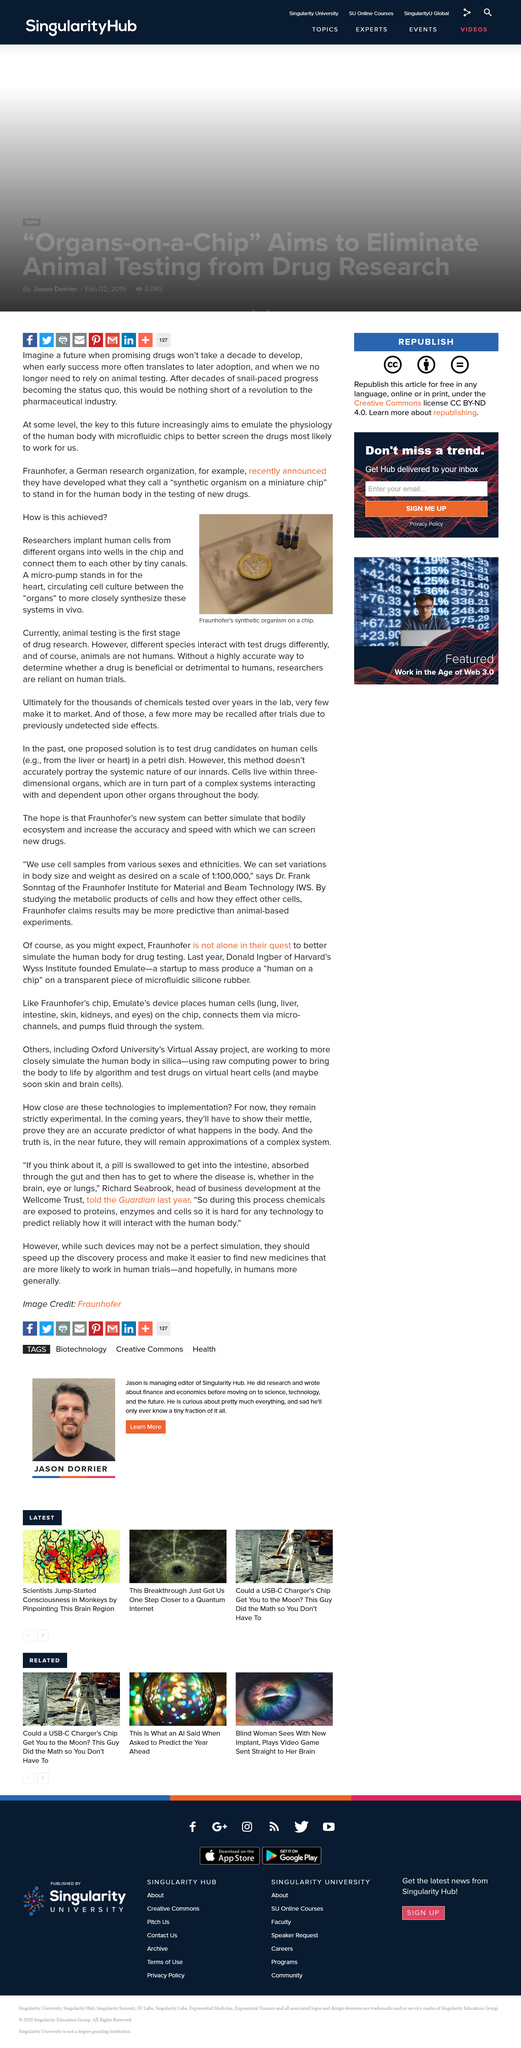Point out several critical features in this image. The effects of test drugs on different species may vary. The initial phase of drug research involves the use of animal testing. Chemicals that have undergone clinical trials may be recalled if previously undetected side effects are discovered. 